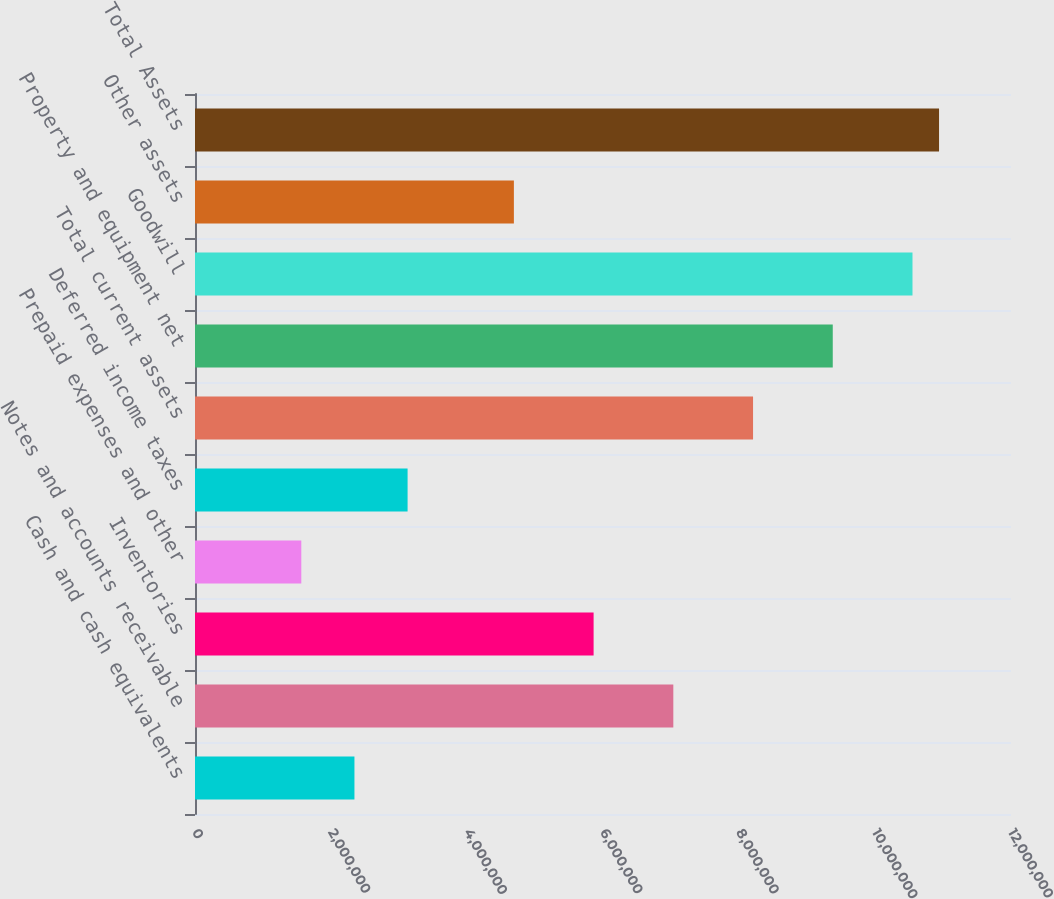<chart> <loc_0><loc_0><loc_500><loc_500><bar_chart><fcel>Cash and cash equivalents<fcel>Notes and accounts receivable<fcel>Inventories<fcel>Prepaid expenses and other<fcel>Deferred income taxes<fcel>Total current assets<fcel>Property and equipment net<fcel>Goodwill<fcel>Other assets<fcel>Total Assets<nl><fcel>2.3448e+06<fcel>7.03413e+06<fcel>5.8618e+06<fcel>1.56324e+06<fcel>3.12635e+06<fcel>8.20646e+06<fcel>9.3788e+06<fcel>1.05511e+07<fcel>4.68946e+06<fcel>1.09419e+07<nl></chart> 